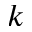<formula> <loc_0><loc_0><loc_500><loc_500>k</formula> 